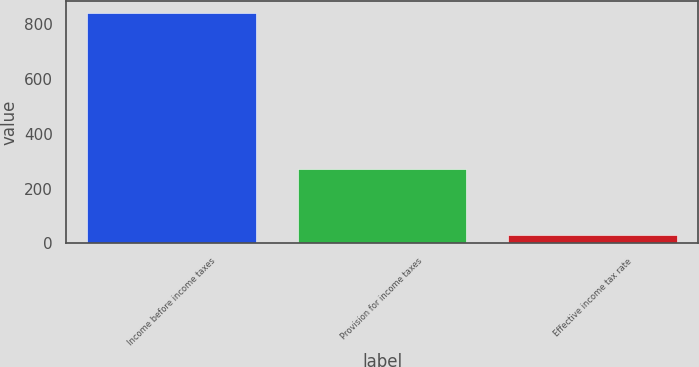Convert chart. <chart><loc_0><loc_0><loc_500><loc_500><bar_chart><fcel>Income before income taxes<fcel>Provision for income taxes<fcel>Effective income tax rate<nl><fcel>840.8<fcel>271.3<fcel>32.3<nl></chart> 